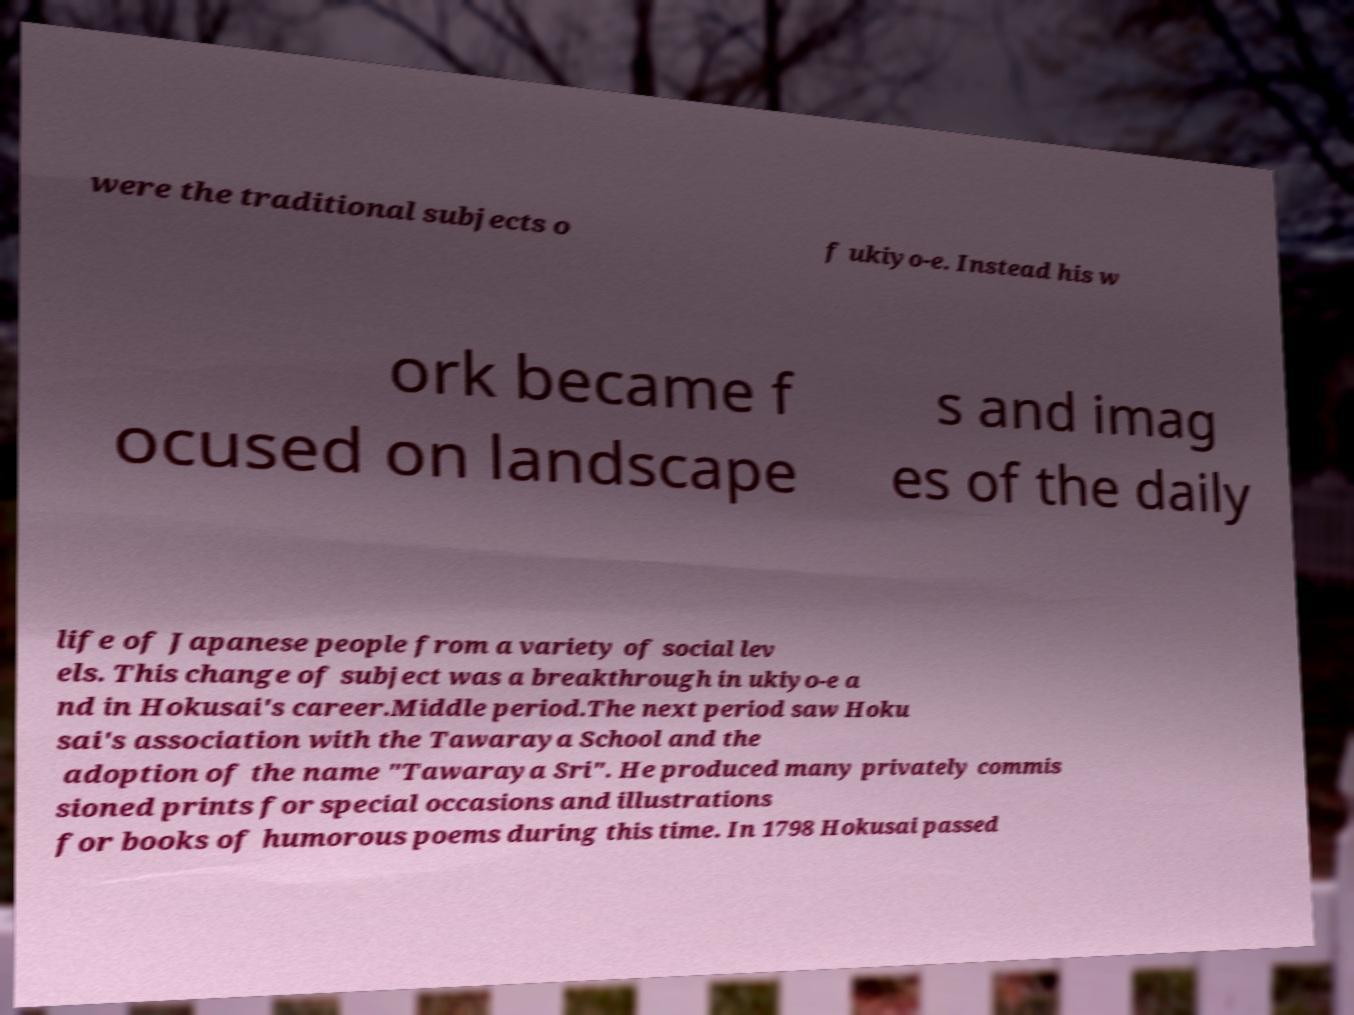Please read and relay the text visible in this image. What does it say? were the traditional subjects o f ukiyo-e. Instead his w ork became f ocused on landscape s and imag es of the daily life of Japanese people from a variety of social lev els. This change of subject was a breakthrough in ukiyo-e a nd in Hokusai's career.Middle period.The next period saw Hoku sai's association with the Tawaraya School and the adoption of the name "Tawaraya Sri". He produced many privately commis sioned prints for special occasions and illustrations for books of humorous poems during this time. In 1798 Hokusai passed 